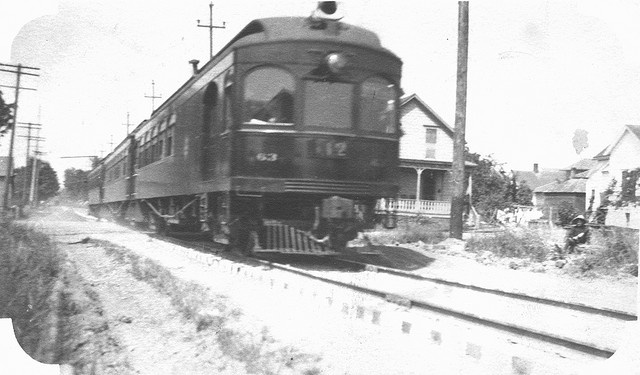Describe the objects in this image and their specific colors. I can see train in white, gray, darkgray, lightgray, and black tones and people in white, gray, darkgray, lightgray, and black tones in this image. 